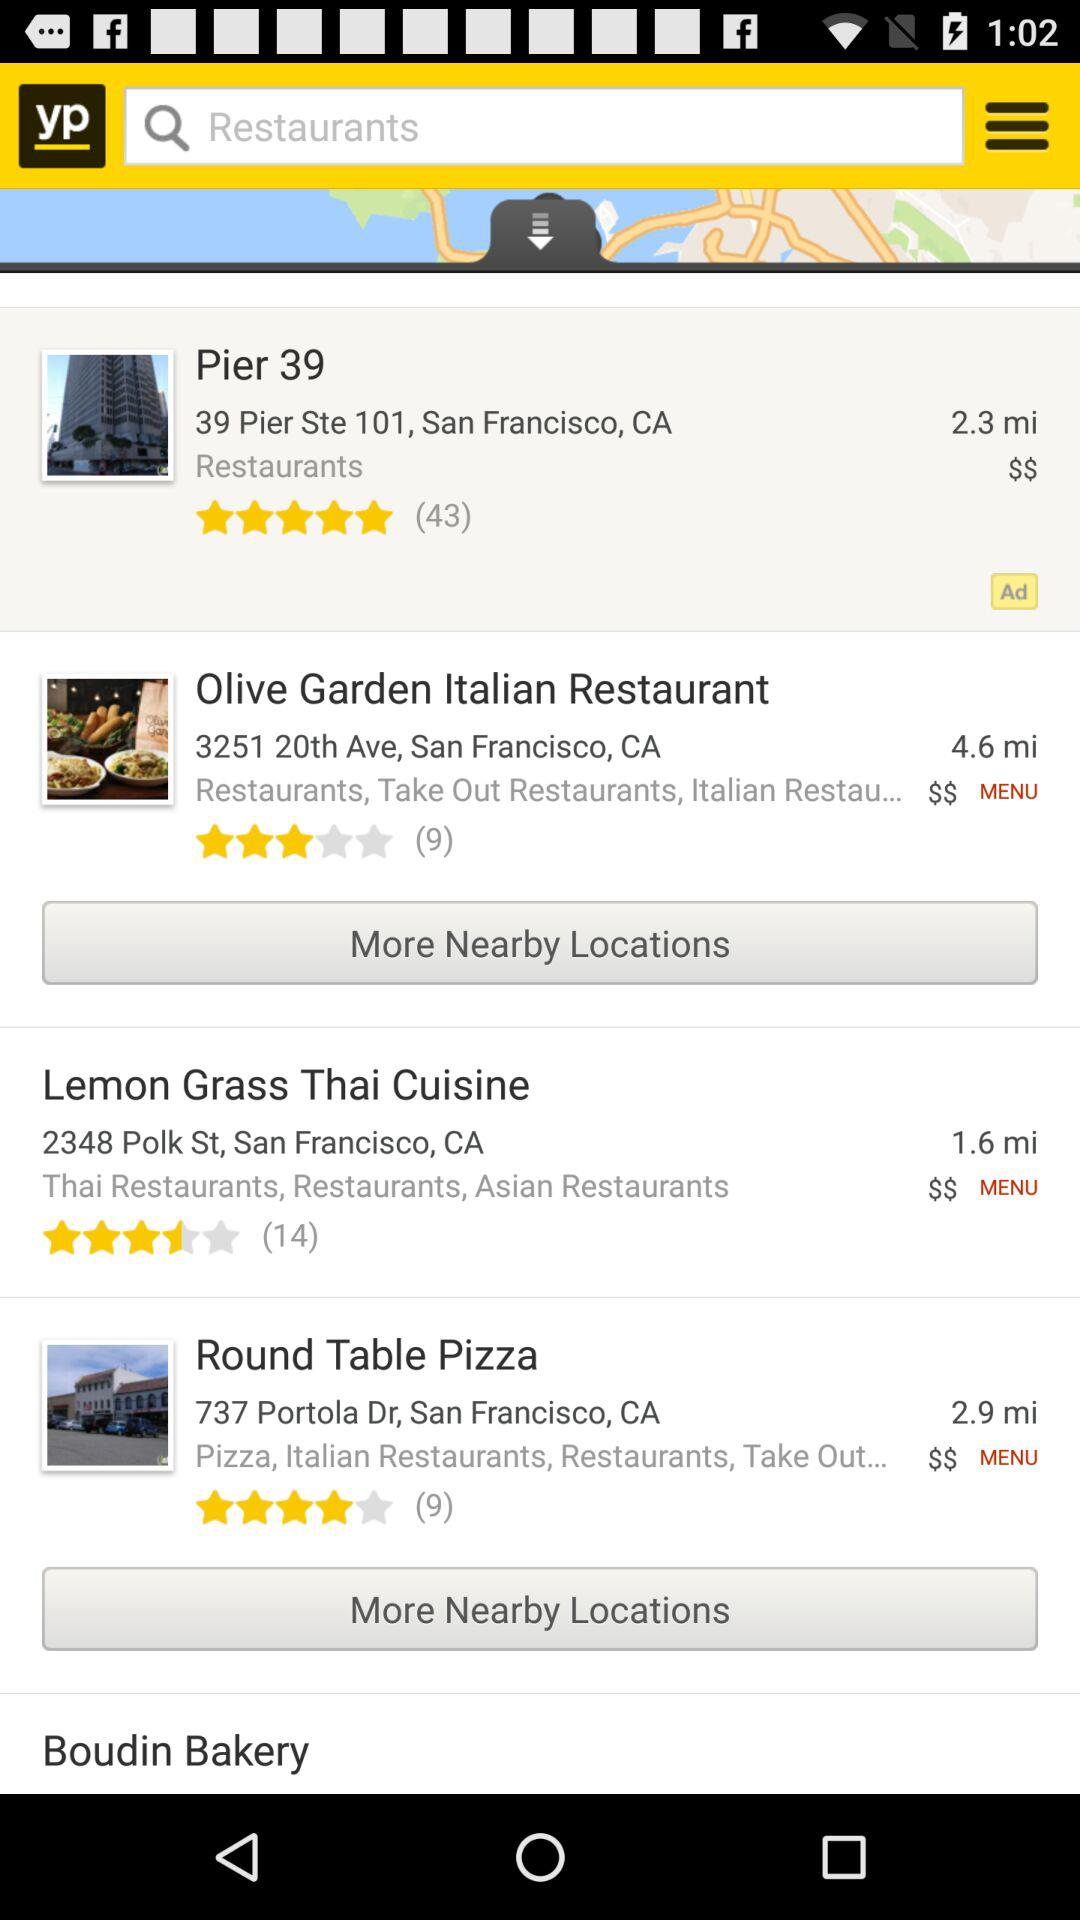How many restaurants are within 3 miles of the current location?
Answer the question using a single word or phrase. 3 